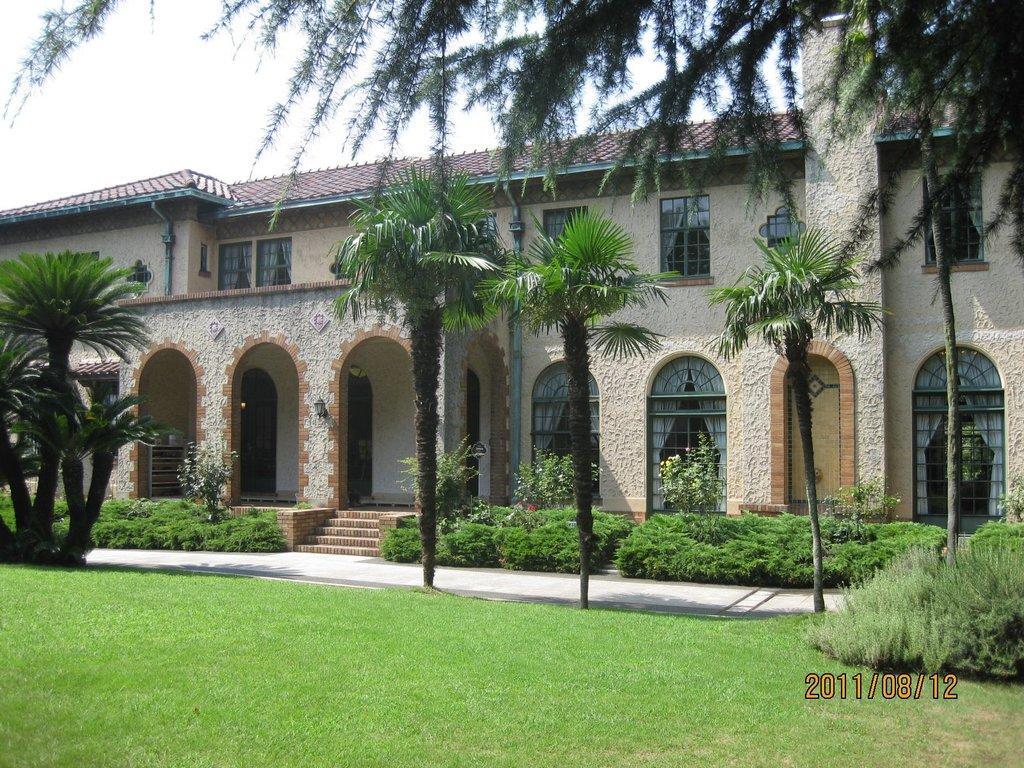Please provide a concise description of this image. In this picture we can see grass, few plants, trees and a building, and we can find few pipes on the walls, at the right bottom of the image we can see timestamp. 